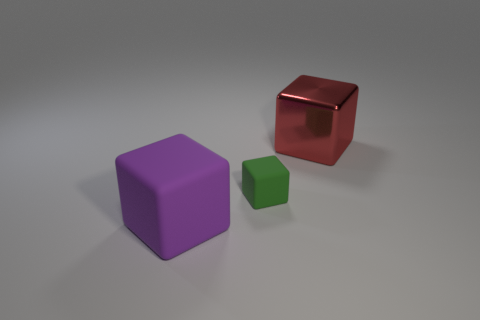What is the size of the red shiny thing on the right side of the big object that is in front of the big thing right of the purple thing?
Give a very brief answer. Large. What is the size of the green rubber thing that is the same shape as the big red thing?
Offer a terse response. Small. How many big things are either purple objects or cyan cylinders?
Your answer should be compact. 1. Are the large object that is behind the small green matte thing and the big block on the left side of the red block made of the same material?
Give a very brief answer. No. What is the material of the big block left of the red shiny cube?
Your response must be concise. Rubber. What number of metal things are tiny purple cylinders or purple things?
Provide a succinct answer. 0. The metallic object that is to the right of the big block that is in front of the metallic cube is what color?
Provide a short and direct response. Red. Is the small green object made of the same material as the block that is on the right side of the green rubber thing?
Provide a short and direct response. No. What color is the large block that is behind the rubber thing that is right of the big block that is on the left side of the metallic block?
Ensure brevity in your answer.  Red. Are there more red rubber spheres than big shiny blocks?
Your answer should be very brief. No. 